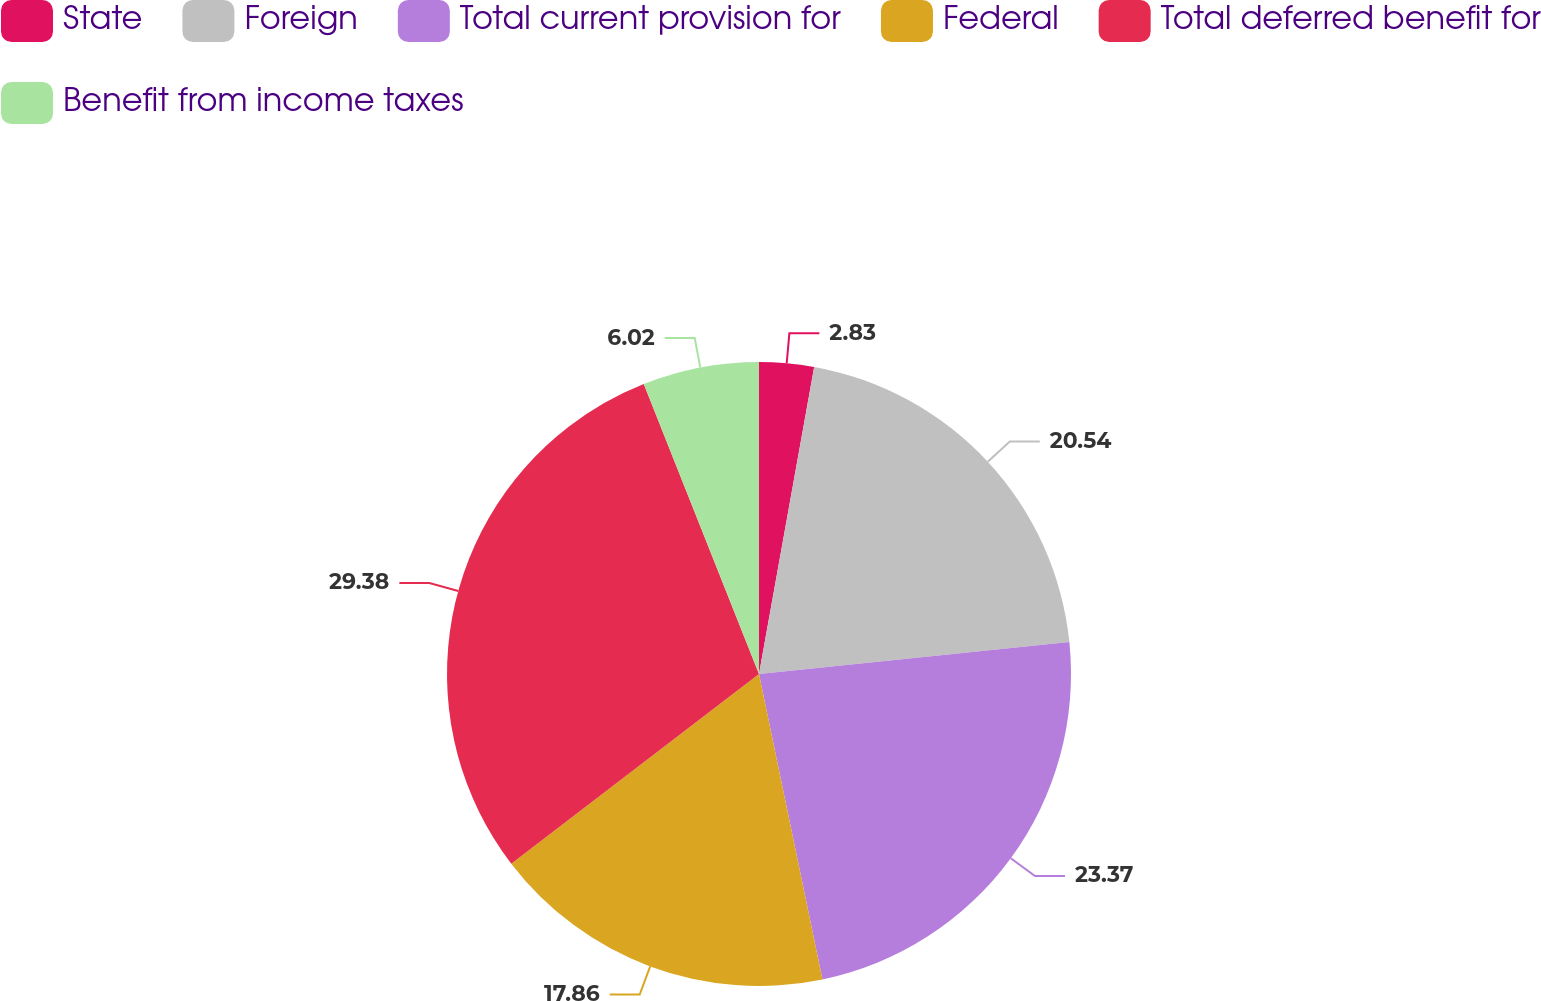Convert chart to OTSL. <chart><loc_0><loc_0><loc_500><loc_500><pie_chart><fcel>State<fcel>Foreign<fcel>Total current provision for<fcel>Federal<fcel>Total deferred benefit for<fcel>Benefit from income taxes<nl><fcel>2.83%<fcel>20.54%<fcel>23.37%<fcel>17.86%<fcel>29.38%<fcel>6.02%<nl></chart> 